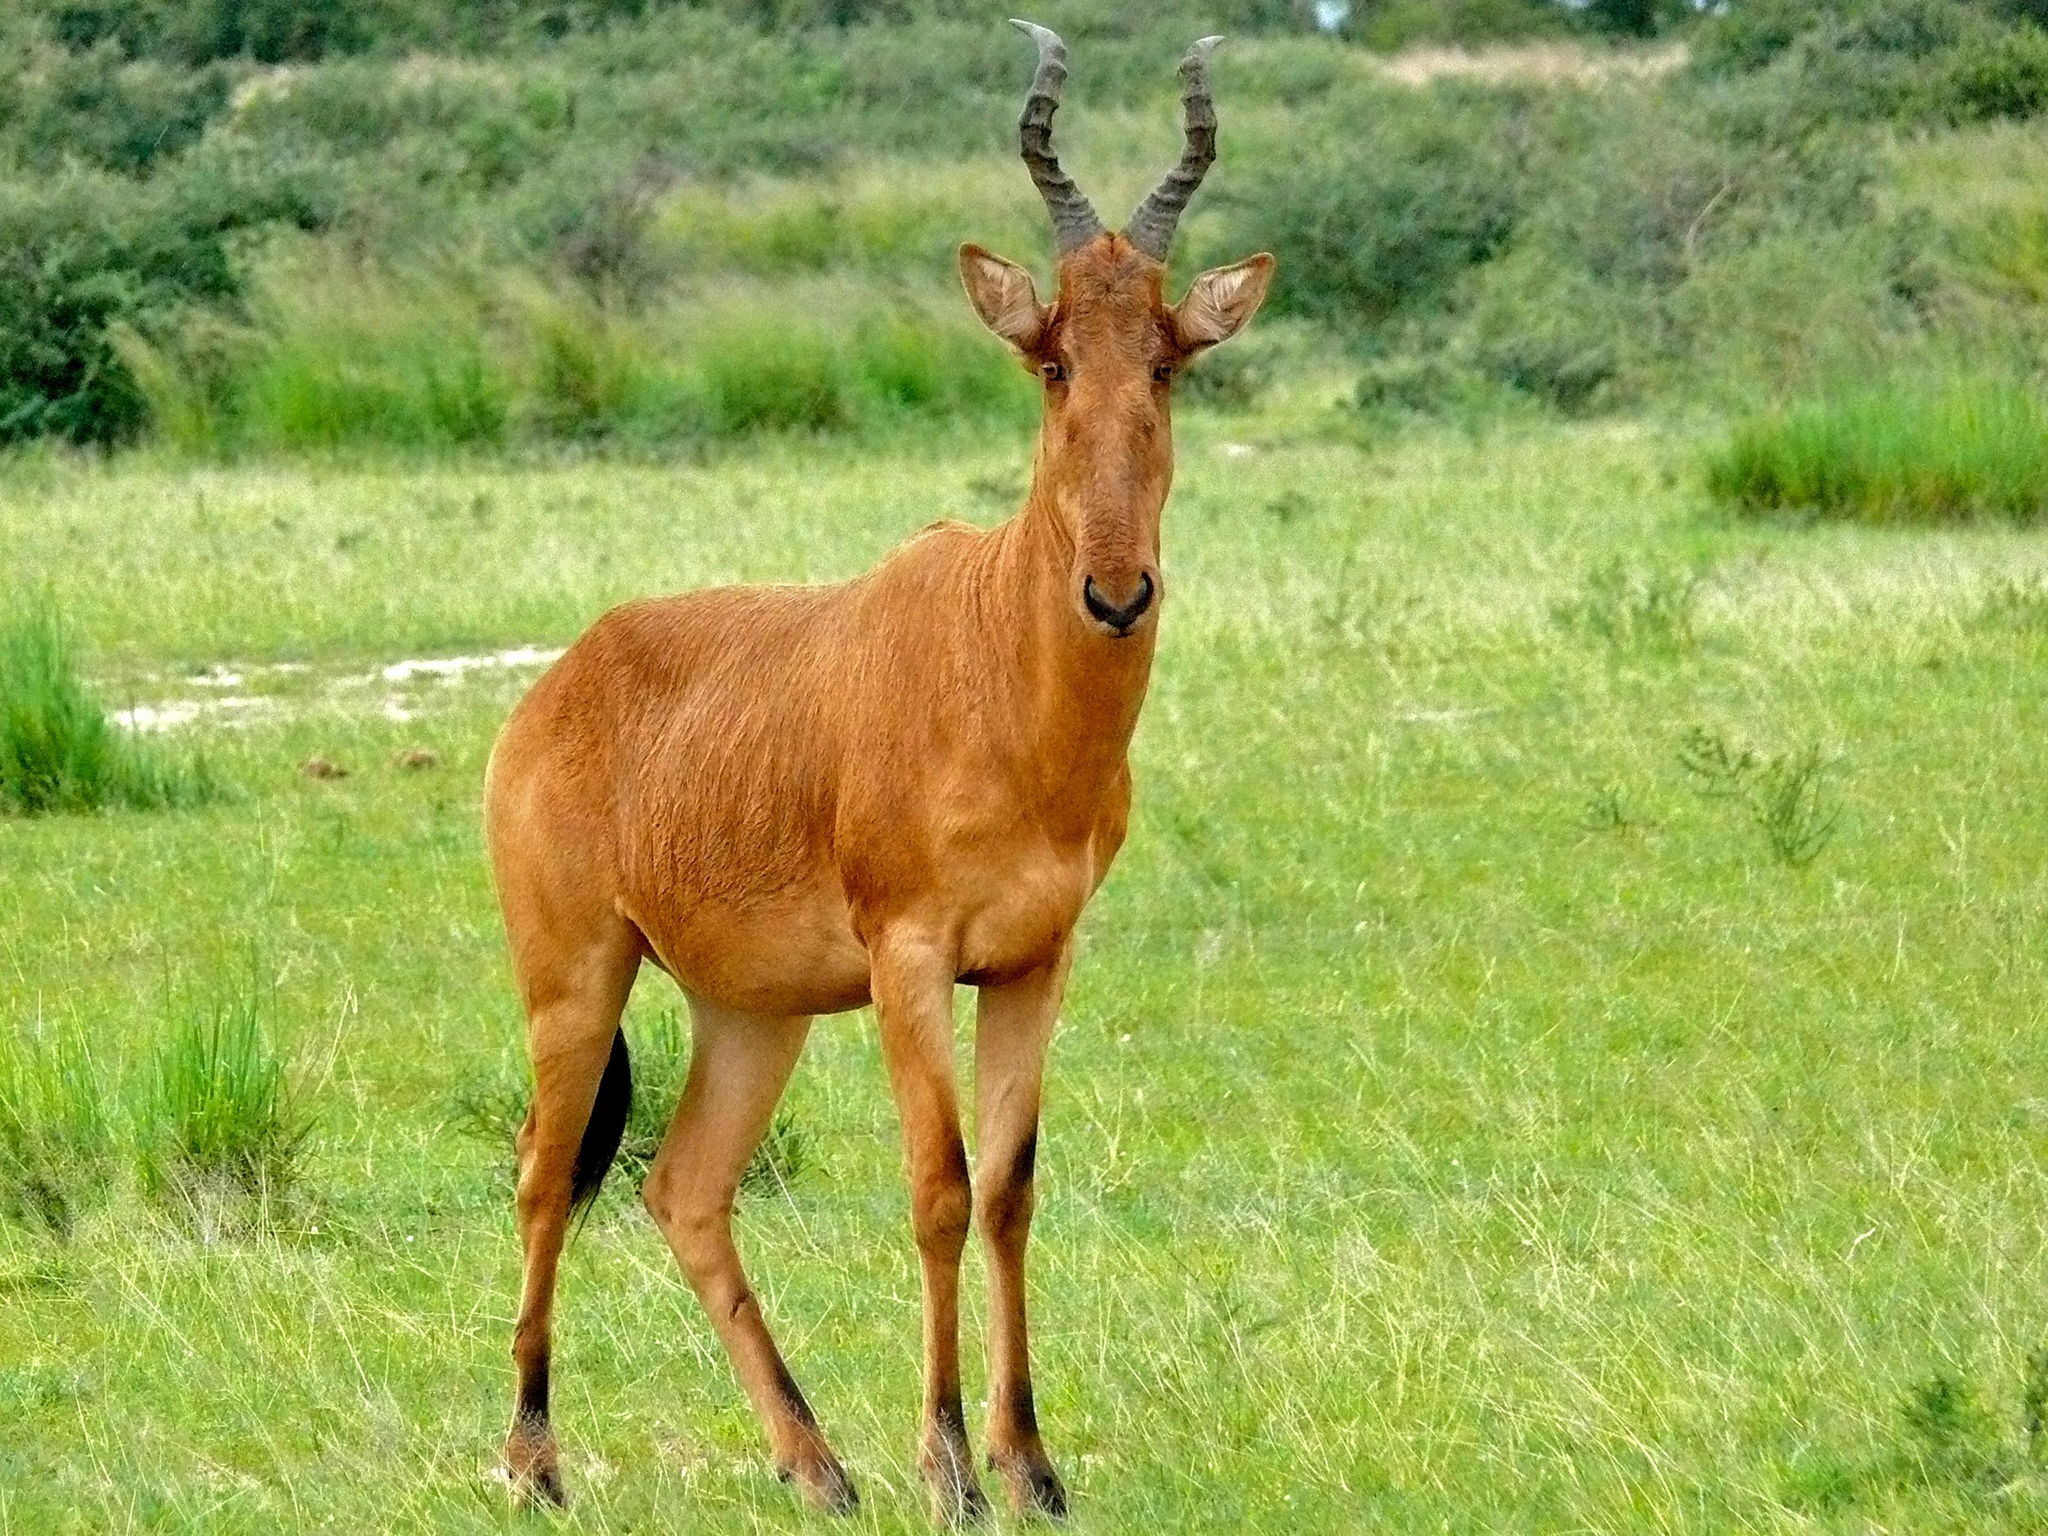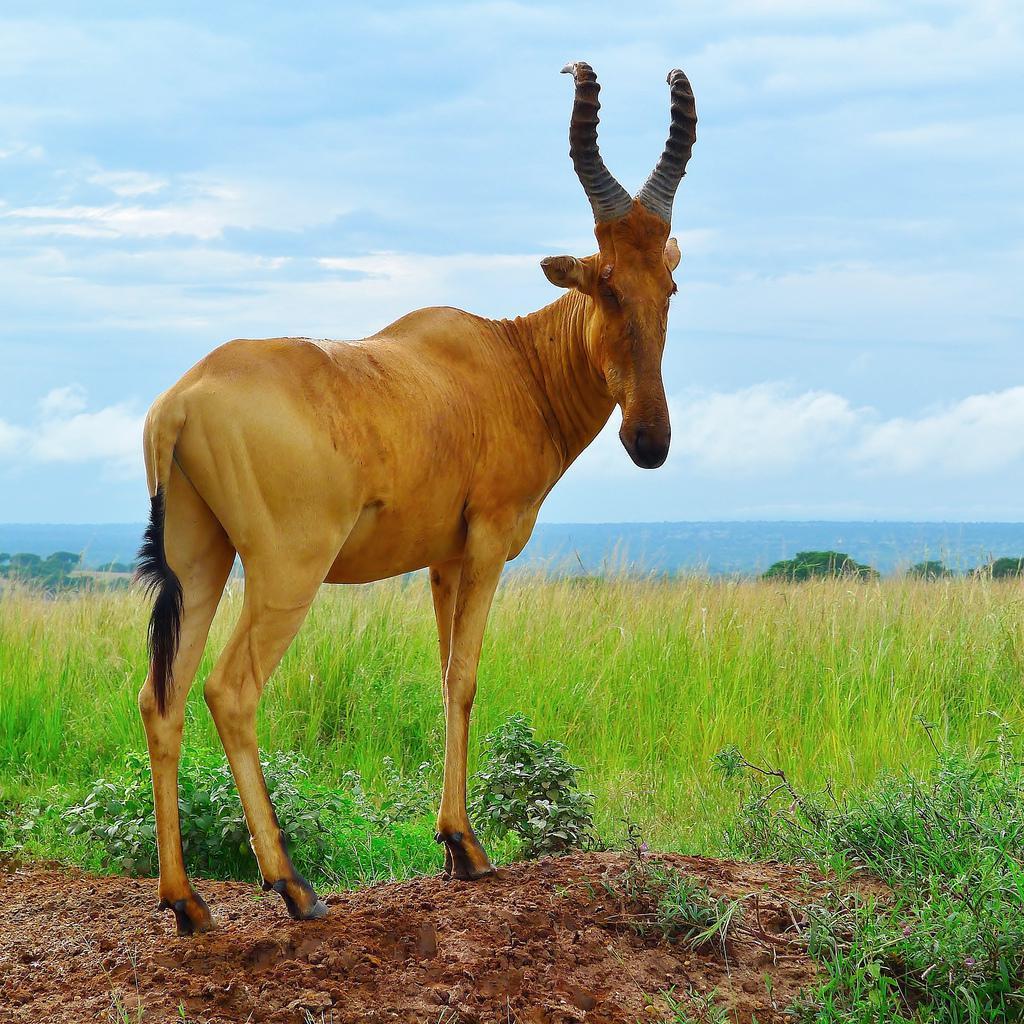The first image is the image on the left, the second image is the image on the right. For the images displayed, is the sentence "Two antelopes are facing the opposite direction than the other." factually correct? Answer yes or no. No. The first image is the image on the left, the second image is the image on the right. Analyze the images presented: Is the assertion "An image contains only one horned animal, which is standing with its head and body turned leftward." valid? Answer yes or no. No. 